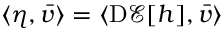Convert formula to latex. <formula><loc_0><loc_0><loc_500><loc_500>\langle \eta , \bar { v } \rangle = \langle D \mathcal { E } [ h ] , \bar { v } \rangle</formula> 